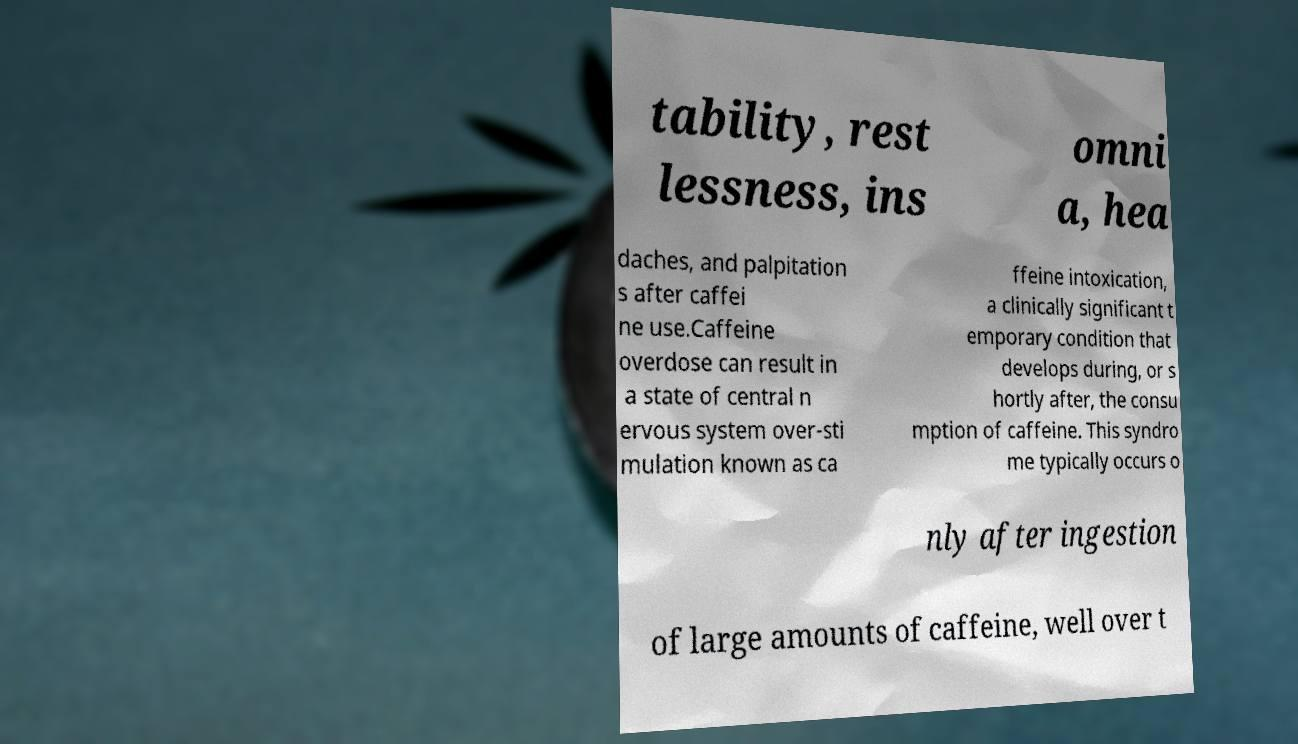I need the written content from this picture converted into text. Can you do that? tability, rest lessness, ins omni a, hea daches, and palpitation s after caffei ne use.Caffeine overdose can result in a state of central n ervous system over-sti mulation known as ca ffeine intoxication, a clinically significant t emporary condition that develops during, or s hortly after, the consu mption of caffeine. This syndro me typically occurs o nly after ingestion of large amounts of caffeine, well over t 